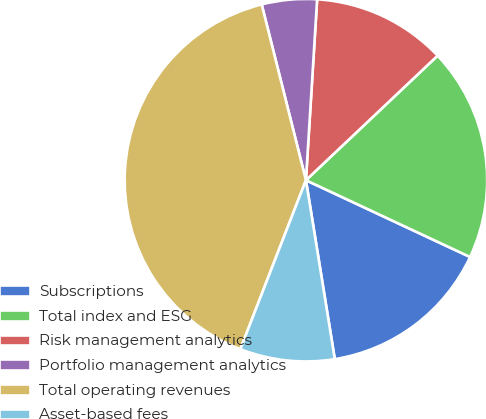<chart> <loc_0><loc_0><loc_500><loc_500><pie_chart><fcel>Subscriptions<fcel>Total index and ESG<fcel>Risk management analytics<fcel>Portfolio management analytics<fcel>Total operating revenues<fcel>Asset-based fees<nl><fcel>15.49%<fcel>19.02%<fcel>11.96%<fcel>4.91%<fcel>40.18%<fcel>8.44%<nl></chart> 